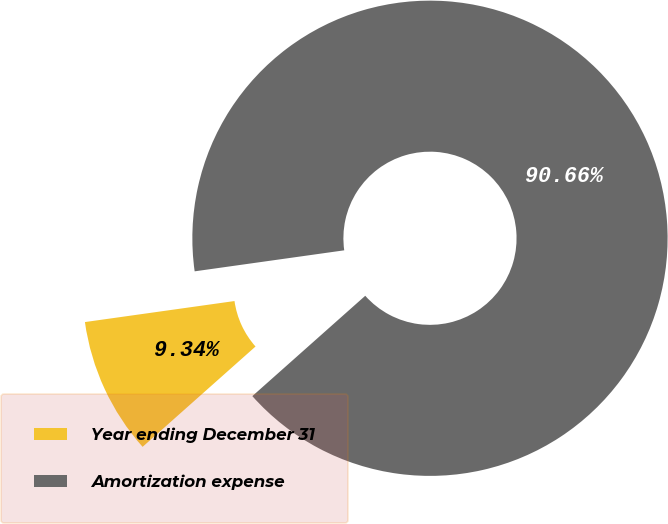Convert chart to OTSL. <chart><loc_0><loc_0><loc_500><loc_500><pie_chart><fcel>Year ending December 31<fcel>Amortization expense<nl><fcel>9.34%<fcel>90.66%<nl></chart> 